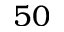<formula> <loc_0><loc_0><loc_500><loc_500>5 0</formula> 